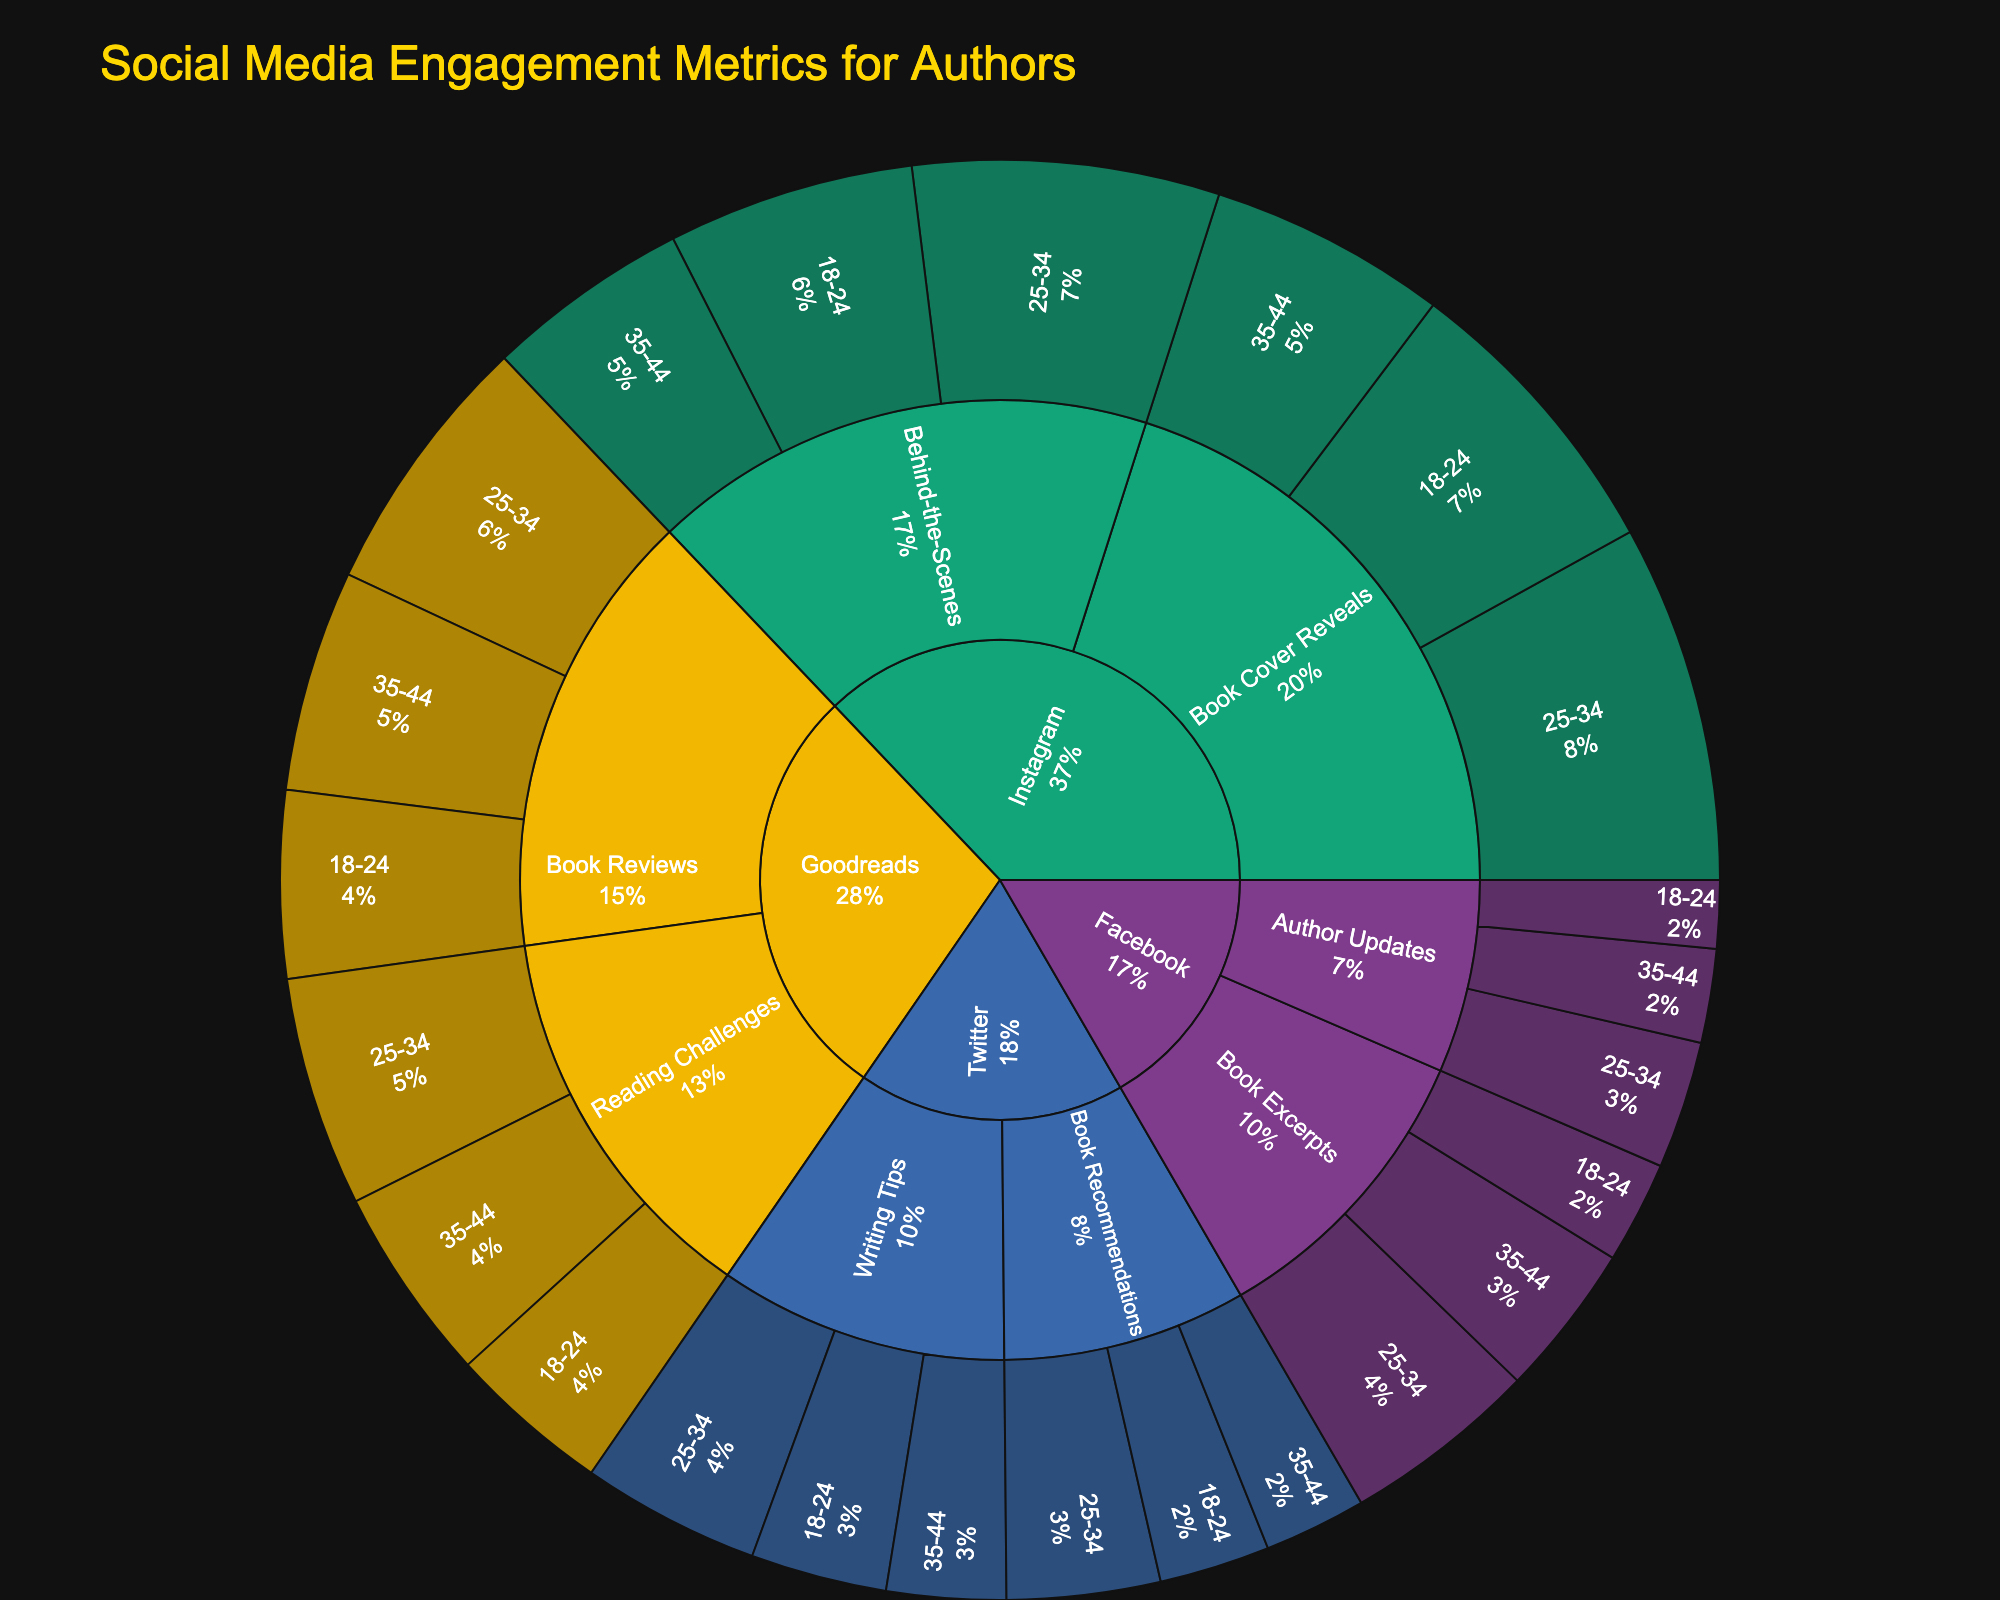1. What is the most engaging platform according to the Sunburst plot? To find the most engaging platform, look at the largest segment in the outer ring of the plot and compare their sizes. The platform with the largest total engagement metrics is the most engaging.
Answer: Instagram 2. How many different demographic groups are shown in the figure? Observe the labels on the innermost ring, which denote the demographic groups corresponding to the engagement data across different platforms and content types. Count the unique demographic group labels.
Answer: 3 3. Among the demographics for Facebook, which content type has the highest engagement for the 25-34 age group? Navigate through the layers for Facebook, then to 25-34 age group, and compare the engagement values of different content types within this group.
Answer: Book Excerpts 4. Compare the engagement between 'Author Updates' on Facebook and 'Writing Tips' on Twitter for the 35-44 age group; which one has higher engagement? Navigate to Facebook → Author Updates → 35-44 and check the engagement value. Then go to Twitter → Writing Tips → 35-44 and compare the engagement value between these two segments.
Answer: Author Updates 5. Which content type on Instagram gets the highest engagement from the 25-34 demographic? Follow the Instagram layer to the 25-34 demographic and compare the engagement values of different content types within this demographic.
Answer: Book Cover Reveals 6. What is the total engagement for the 'Book Reviews' content type across all demographics on Goodreads? Sum the engagement values for 'Book Reviews' under each demographic on Goodreads. This requires adding the engagement: 18-24 (2200) + 25-34 (3100) + 35-44 (2600). The total is 2200 + 3100 + 2600.
Answer: 7900 7. Which platform sees the least engagement for the '18-24' demographic based on the Sunburst plot? Inspect each platform's segment for the 18-24 demographic and compare the engagement values to find the smallest one.
Answer: Facebook 8. Between Facebook and Twitter, which platform has higher engagement for 'Book Excerpts' content type for all age groups? Add the engagement values for 'Book Excerpts' on Facebook across all age groups and then do the same for Twitter. Compare the sums to identify which is higher. For Facebook: 1200 + 2300 + 1800 = 5300. For Twitter: 1600 + 2100 + 1400 = 5100.
Answer: Facebook 9. What is the total engagement from the 18-24 demographic across all platforms and content types? Sum the engagement values from the 18-24 demographic across all platforms and content types: 1200 (FB) + 800 (FB) + 3500 (IG) + 2900 (IG) + 1600 (TW) + 1300 (TW) + 2200 (GR) + 1900 (GR). The total is 14300.
Answer: 14300 10. Which content type on Instagram has lower engagement for the 35-44 age group compared to Facebook? Compare the engagement values for each content type on Instagram with the corresponding values on Facebook for the 35-44 demographic. Look for the content type on Instagram with lower engagement.
Answer: Behind-the-Scenes 